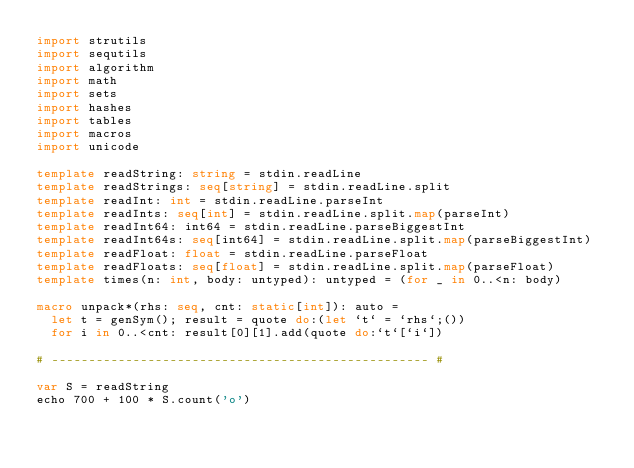Convert code to text. <code><loc_0><loc_0><loc_500><loc_500><_Nim_>import strutils
import sequtils
import algorithm
import math
import sets
import hashes
import tables
import macros
import unicode

template readString: string = stdin.readLine
template readStrings: seq[string] = stdin.readLine.split
template readInt: int = stdin.readLine.parseInt
template readInts: seq[int] = stdin.readLine.split.map(parseInt)
template readInt64: int64 = stdin.readLine.parseBiggestInt
template readInt64s: seq[int64] = stdin.readLine.split.map(parseBiggestInt)
template readFloat: float = stdin.readLine.parseFloat
template readFloats: seq[float] = stdin.readLine.split.map(parseFloat)
template times(n: int, body: untyped): untyped = (for _ in 0..<n: body)

macro unpack*(rhs: seq, cnt: static[int]): auto =
  let t = genSym(); result = quote do:(let `t` = `rhs`;())
  for i in 0..<cnt: result[0][1].add(quote do:`t`[`i`])

# --------------------------------------------------- #

var S = readString
echo 700 + 100 * S.count('o')</code> 